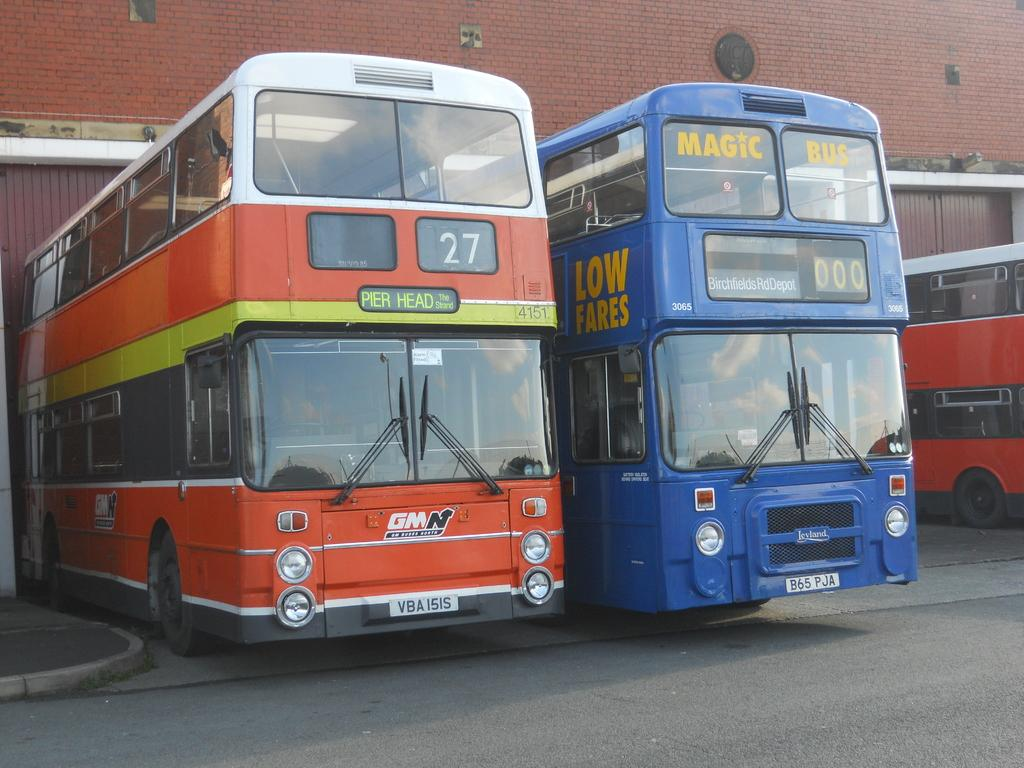What type of vehicles can be seen on the road in the image? There are buses on the road in the image. What can be seen in the background of the image? There is a wall visible in the background of the image, as well as some unspecified objects. How many times does the group sneeze in the image? There is no group or sneezing present in the image. 